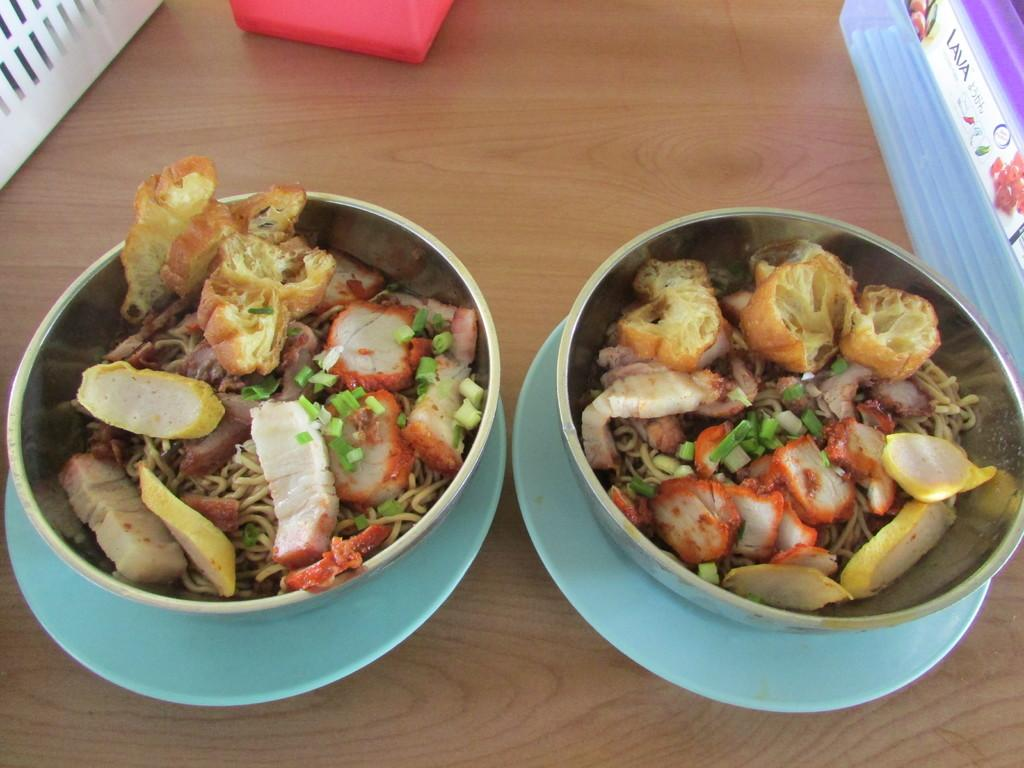What is in the bowl that is visible in the image? There are food items in a bowl in the image. How is the bowl positioned in relation to other objects? The bowl is placed on a plate. What type of surface is the plate resting on? The plate is on a wooden surface. Can you describe any other objects in the image? There are additional objects in the image, but their specific details are not mentioned in the provided facts. Is there a hole in the wooden surface where the plate is resting? There is no mention of a hole in the wooden surface in the provided facts, so it cannot be determined from the image. 